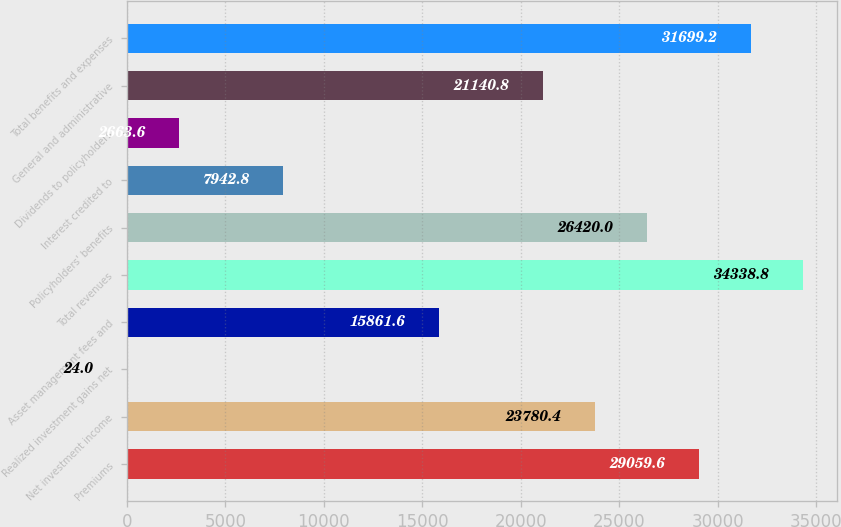Convert chart to OTSL. <chart><loc_0><loc_0><loc_500><loc_500><bar_chart><fcel>Premiums<fcel>Net investment income<fcel>Realized investment gains net<fcel>Asset management fees and<fcel>Total revenues<fcel>Policyholders' benefits<fcel>Interest credited to<fcel>Dividends to policyholders<fcel>General and administrative<fcel>Total benefits and expenses<nl><fcel>29059.6<fcel>23780.4<fcel>24<fcel>15861.6<fcel>34338.8<fcel>26420<fcel>7942.8<fcel>2663.6<fcel>21140.8<fcel>31699.2<nl></chart> 